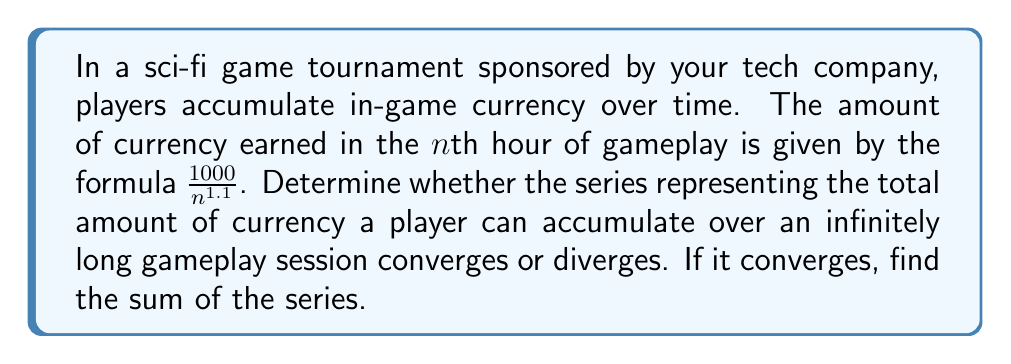Provide a solution to this math problem. To analyze the convergence of this series, we need to consider the infinite series:

$$\sum_{n=1}^{\infty} \frac{1000}{n^{1.1}}$$

We can approach this problem using the following steps:

1) First, we can factor out the constant 1000:

   $$1000 \sum_{n=1}^{\infty} \frac{1}{n^{1.1}}$$

2) Now, we recognize this as a p-series of the form $\sum_{n=1}^{\infty} \frac{1}{n^p}$, where $p = 1.1$.

3) For a p-series:
   - If $p > 1$, the series converges.
   - If $p \leq 1$, the series diverges.

4) In our case, $p = 1.1 > 1$, so the series converges.

5) To find the sum of the series, we can use the fact that for a p-series with $p > 1$:

   $$\sum_{n=1}^{\infty} \frac{1}{n^p} = \zeta(p)$$

   where $\zeta(p)$ is the Riemann zeta function.

6) For $p = 1.1$, we have $\zeta(1.1) \approx 10.5845$.

7) Therefore, the sum of our original series is:

   $$1000 \cdot \zeta(1.1) \approx 1000 \cdot 10.5845 = 10,584.5$$
Answer: The series converges, and the sum is approximately 10,584.5 units of in-game currency. 